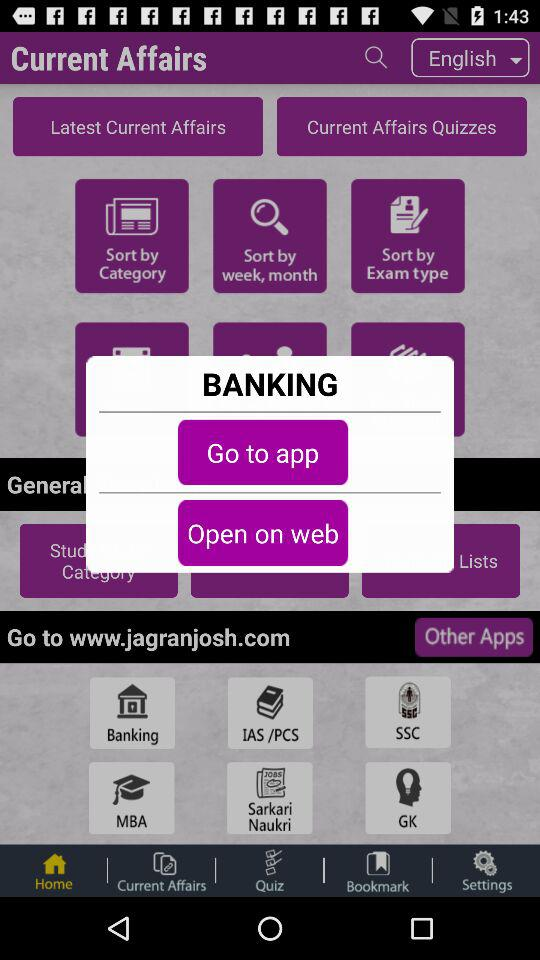Which tab is selected? The selected tab is "Home". 